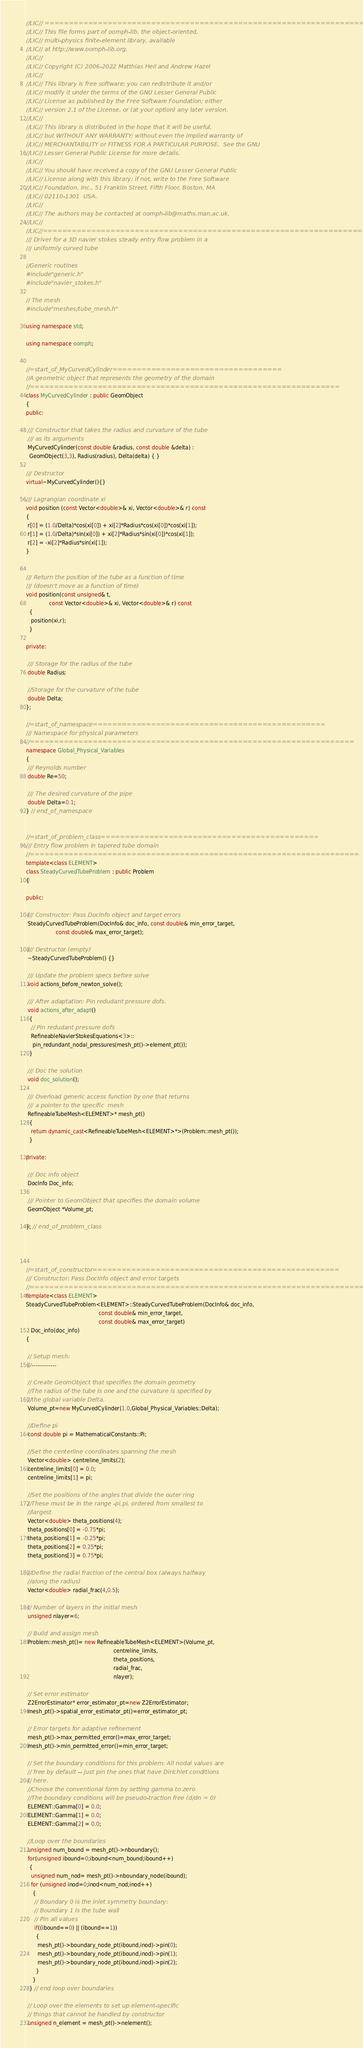<code> <loc_0><loc_0><loc_500><loc_500><_C++_>//LIC// ====================================================================
//LIC// This file forms part of oomph-lib, the object-oriented, 
//LIC// multi-physics finite-element library, available 
//LIC// at http://www.oomph-lib.org.
//LIC// 
//LIC// Copyright (C) 2006-2022 Matthias Heil and Andrew Hazel
//LIC// 
//LIC// This library is free software; you can redistribute it and/or
//LIC// modify it under the terms of the GNU Lesser General Public
//LIC// License as published by the Free Software Foundation; either
//LIC// version 2.1 of the License, or (at your option) any later version.
//LIC// 
//LIC// This library is distributed in the hope that it will be useful,
//LIC// but WITHOUT ANY WARRANTY; without even the implied warranty of
//LIC// MERCHANTABILITY or FITNESS FOR A PARTICULAR PURPOSE.  See the GNU
//LIC// Lesser General Public License for more details.
//LIC// 
//LIC// You should have received a copy of the GNU Lesser General Public
//LIC// License along with this library; if not, write to the Free Software
//LIC// Foundation, Inc., 51 Franklin Street, Fifth Floor, Boston, MA
//LIC// 02110-1301  USA.
//LIC// 
//LIC// The authors may be contacted at oomph-lib@maths.man.ac.uk.
//LIC// 
//LIC//====================================================================
/// Driver for a 3D navier stokes steady entry flow problem in a 
/// uniformly curved tube

//Generic routines
#include "generic.h"
#include "navier_stokes.h"

// The mesh
#include "meshes/tube_mesh.h"

using namespace std;

using namespace oomph;


//=start_of_MyCurvedCylinder===================================
//A geometric object that represents the geometry of the domain
//================================================================
class MyCurvedCylinder : public GeomObject
{
public:

 /// Constructor that takes the radius and curvature of the tube
 /// as its arguments
 MyCurvedCylinder(const double &radius, const double &delta) :
  GeomObject(3,3), Radius(radius), Delta(delta) { }
 
/// Destructor
virtual~MyCurvedCylinder(){}

/// Lagrangian coordinate xi
void position (const Vector<double>& xi, Vector<double>& r) const
{
 r[0] = (1.0/Delta)*cos(xi[0]) + xi[2]*Radius*cos(xi[0])*cos(xi[1]);
 r[1] = (1.0/Delta)*sin(xi[0]) + xi[2]*Radius*sin(xi[0])*cos(xi[1]);
 r[2] = -xi[2]*Radius*sin(xi[1]);
}


/// Return the position of the tube as a function of time 
/// (doesn't move as a function of time)
void position(const unsigned& t, 
              const Vector<double>& xi, Vector<double>& r) const
  {
   position(xi,r);
  }

private:

 /// Storage for the radius of the tube
 double Radius;

 //Storage for the curvature of the tube
 double Delta;
};

//=start_of_namespace================================================
/// Namespace for physical parameters
//===================================================================
namespace Global_Physical_Variables
{
 /// Reynolds number
 double Re=50;
 
 /// The desired curvature of the pipe
 double Delta=0.1;
} // end_of_namespace


//=start_of_problem_class=============================================
/// Entry flow problem in tapered tube domain
//====================================================================
template<class ELEMENT>
class SteadyCurvedTubeProblem : public Problem
{

public:

 /// Constructor: Pass DocInfo object and target errors
 SteadyCurvedTubeProblem(DocInfo& doc_info, const double& min_error_target,
                  const double& max_error_target);

 /// Destructor (empty)
 ~SteadyCurvedTubeProblem() {}

 /// Update the problem specs before solve 
 void actions_before_newton_solve();

 /// After adaptation: Pin redudant pressure dofs.
 void actions_after_adapt()
  {
   // Pin redudant pressure dofs
   RefineableNavierStokesEquations<3>::
    pin_redundant_nodal_pressures(mesh_pt()->element_pt());
  } 

 /// Doc the solution
 void doc_solution();

 /// Overload generic access function by one that returns
 /// a pointer to the specific  mesh
 RefineableTubeMesh<ELEMENT>* mesh_pt() 
  {
   return dynamic_cast<RefineableTubeMesh<ELEMENT>*>(Problem::mesh_pt());
  }

private:
 
 /// Doc info object
 DocInfo Doc_info;
 
 /// Pointer to GeomObject that specifies the domain volume
 GeomObject *Volume_pt;

}; // end_of_problem_class




//=start_of_constructor===================================================
/// Constructor: Pass DocInfo object and error targets
//========================================================================
template<class ELEMENT>
SteadyCurvedTubeProblem<ELEMENT>::SteadyCurvedTubeProblem(DocInfo& doc_info,
                                            const double& min_error_target,
                                            const double& max_error_target) 
 : Doc_info(doc_info)
{ 

 // Setup mesh:
 //------------

 // Create GeomObject that specifies the domain geometry
 //The radius of the tube is one and the curvature is specified by
 //the global variable Delta.
 Volume_pt=new MyCurvedCylinder(1.0,Global_Physical_Variables::Delta);
 
 //Define pi 
 const double pi = MathematicalConstants::Pi;
 
 //Set the centerline coordinates spanning the mesh
 Vector<double> centreline_limits(2);
 centreline_limits[0] = 0.0;
 centreline_limits[1] = pi;

 //Set the positions of the angles that divide the outer ring
 //These must be in the range -pi,pi, ordered from smallest to
 //largest
 Vector<double> theta_positions(4);
 theta_positions[0] = -0.75*pi;
 theta_positions[1] = -0.25*pi;
 theta_positions[2] = 0.25*pi;
 theta_positions[3] = 0.75*pi;

 //Define the radial fraction of the central box (always halfway
 //along the radius)
 Vector<double> radial_frac(4,0.5);
 
 // Number of layers in the initial mesh
 unsigned nlayer=6;

 // Build and assign mesh
 Problem::mesh_pt()= new RefineableTubeMesh<ELEMENT>(Volume_pt,
                                                     centreline_limits,
                                                     theta_positions,
                                                     radial_frac,
                                                     nlayer);
 
 // Set error estimator 
 Z2ErrorEstimator* error_estimator_pt=new Z2ErrorEstimator;
 mesh_pt()->spatial_error_estimator_pt()=error_estimator_pt;
 
 // Error targets for adaptive refinement
 mesh_pt()->max_permitted_error()=max_error_target; 
 mesh_pt()->min_permitted_error()=min_error_target; 
 
 // Set the boundary conditions for this problem: All nodal values are
 // free by default -- just pin the ones that have Dirichlet conditions
 // here. 
 //Choose the conventional form by setting gamma to zero
 //The boundary conditions will be pseudo-traction free (d/dn = 0)
 ELEMENT::Gamma[0] = 0.0;
 ELEMENT::Gamma[1] = 0.0;
 ELEMENT::Gamma[2] = 0.0;

 //Loop over the boundaries
 unsigned num_bound = mesh_pt()->nboundary();
 for(unsigned ibound=0;ibound<num_bound;ibound++)
  {
   unsigned num_nod= mesh_pt()->nboundary_node(ibound);
   for (unsigned inod=0;inod<num_nod;inod++)
    {
     // Boundary 0 is the inlet symmetry boundary: 
     // Boundary 1 is the tube wall
     // Pin all values
     if((ibound==0) || (ibound==1))
      {
       mesh_pt()->boundary_node_pt(ibound,inod)->pin(0);
       mesh_pt()->boundary_node_pt(ibound,inod)->pin(1);
       mesh_pt()->boundary_node_pt(ibound,inod)->pin(2);
      }
    }
  } // end loop over boundaries

 // Loop over the elements to set up element-specific 
 // things that cannot be handled by constructor
 unsigned n_element = mesh_pt()->nelement();</code> 